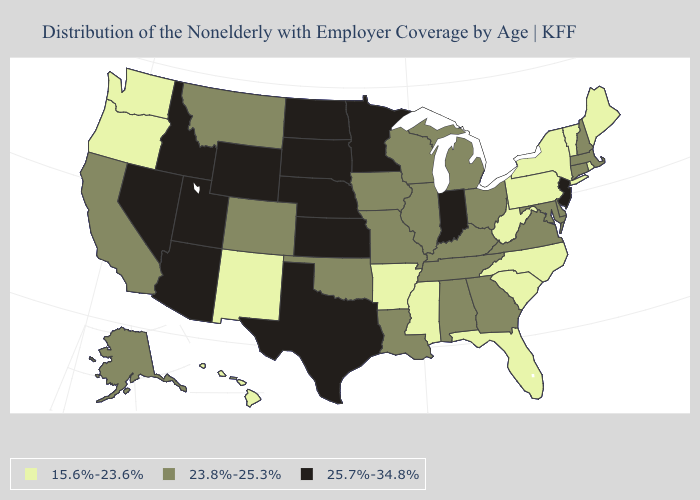Among the states that border Pennsylvania , which have the lowest value?
Concise answer only. New York, West Virginia. Name the states that have a value in the range 23.8%-25.3%?
Be succinct. Alabama, Alaska, California, Colorado, Connecticut, Delaware, Georgia, Illinois, Iowa, Kentucky, Louisiana, Maryland, Massachusetts, Michigan, Missouri, Montana, New Hampshire, Ohio, Oklahoma, Tennessee, Virginia, Wisconsin. Name the states that have a value in the range 15.6%-23.6%?
Concise answer only. Arkansas, Florida, Hawaii, Maine, Mississippi, New Mexico, New York, North Carolina, Oregon, Pennsylvania, Rhode Island, South Carolina, Vermont, Washington, West Virginia. What is the lowest value in states that border Arizona?
Short answer required. 15.6%-23.6%. What is the value of Oregon?
Concise answer only. 15.6%-23.6%. Does Pennsylvania have the highest value in the Northeast?
Write a very short answer. No. Does Missouri have the same value as Vermont?
Concise answer only. No. Among the states that border Michigan , which have the lowest value?
Quick response, please. Ohio, Wisconsin. Among the states that border Arkansas , does Missouri have the lowest value?
Concise answer only. No. Does Hawaii have the lowest value in the USA?
Give a very brief answer. Yes. What is the value of Pennsylvania?
Concise answer only. 15.6%-23.6%. Among the states that border Virginia , does West Virginia have the lowest value?
Concise answer only. Yes. Does Wyoming have the same value as Minnesota?
Concise answer only. Yes. What is the value of Arkansas?
Give a very brief answer. 15.6%-23.6%. 